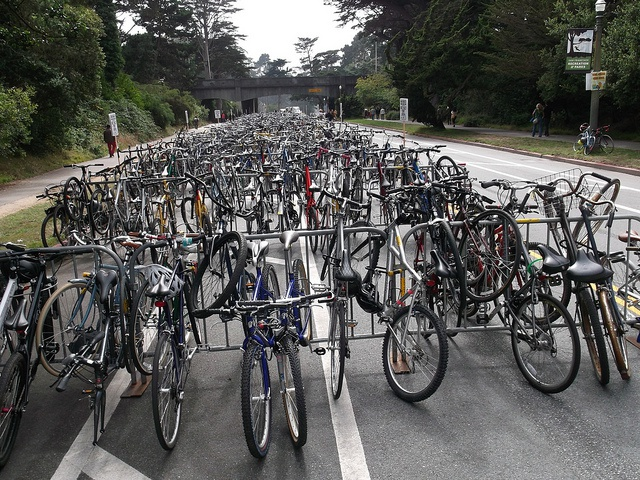Describe the objects in this image and their specific colors. I can see bicycle in black, gray, darkgray, and lightgray tones, bicycle in black, gray, darkgray, and lightgray tones, bicycle in black, gray, darkgray, and lightgray tones, bicycle in black, gray, darkgray, and lightgray tones, and bicycle in black, gray, darkgray, and navy tones in this image. 